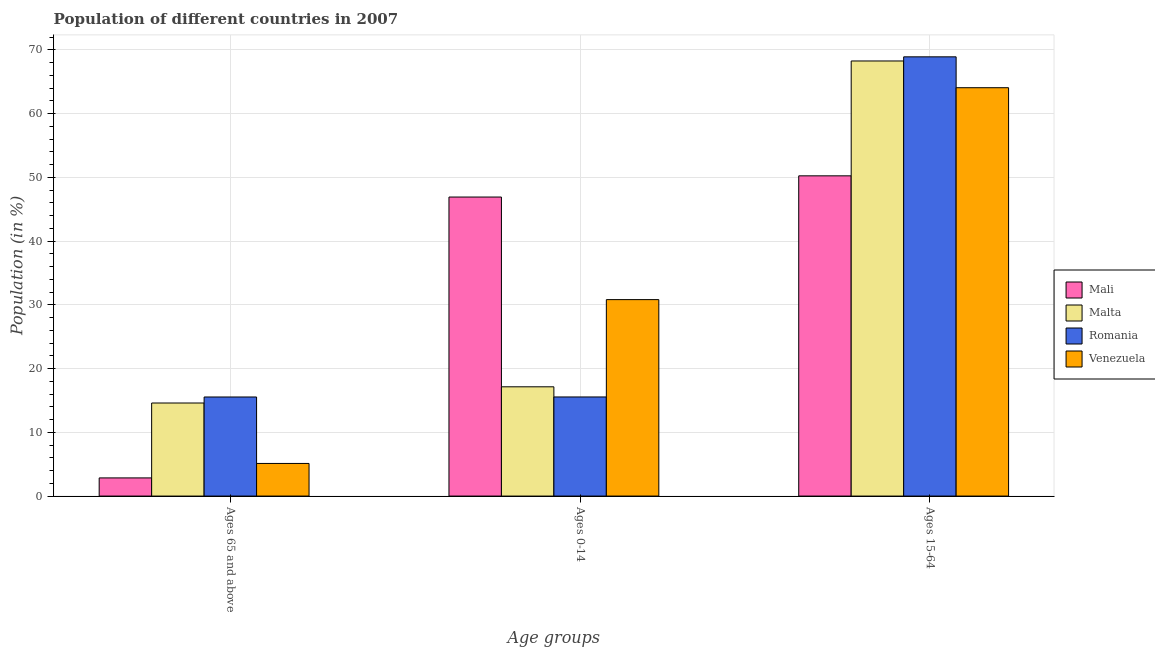How many different coloured bars are there?
Make the answer very short. 4. How many groups of bars are there?
Offer a very short reply. 3. How many bars are there on the 1st tick from the left?
Give a very brief answer. 4. What is the label of the 3rd group of bars from the left?
Make the answer very short. Ages 15-64. What is the percentage of population within the age-group of 65 and above in Romania?
Offer a terse response. 15.54. Across all countries, what is the maximum percentage of population within the age-group of 65 and above?
Provide a short and direct response. 15.54. Across all countries, what is the minimum percentage of population within the age-group 0-14?
Make the answer very short. 15.55. In which country was the percentage of population within the age-group 0-14 maximum?
Ensure brevity in your answer.  Mali. In which country was the percentage of population within the age-group 15-64 minimum?
Provide a short and direct response. Mali. What is the total percentage of population within the age-group of 65 and above in the graph?
Offer a very short reply. 38.11. What is the difference between the percentage of population within the age-group 0-14 in Mali and that in Romania?
Keep it short and to the point. 31.36. What is the difference between the percentage of population within the age-group 15-64 in Romania and the percentage of population within the age-group of 65 and above in Venezuela?
Ensure brevity in your answer.  63.79. What is the average percentage of population within the age-group 15-64 per country?
Offer a very short reply. 62.87. What is the difference between the percentage of population within the age-group 0-14 and percentage of population within the age-group of 65 and above in Romania?
Offer a terse response. 0. What is the ratio of the percentage of population within the age-group 0-14 in Venezuela to that in Mali?
Ensure brevity in your answer.  0.66. What is the difference between the highest and the second highest percentage of population within the age-group of 65 and above?
Offer a very short reply. 0.94. What is the difference between the highest and the lowest percentage of population within the age-group of 65 and above?
Your answer should be very brief. 12.7. In how many countries, is the percentage of population within the age-group 0-14 greater than the average percentage of population within the age-group 0-14 taken over all countries?
Provide a short and direct response. 2. What does the 4th bar from the left in Ages 65 and above represents?
Your answer should be very brief. Venezuela. What does the 2nd bar from the right in Ages 65 and above represents?
Give a very brief answer. Romania. Is it the case that in every country, the sum of the percentage of population within the age-group of 65 and above and percentage of population within the age-group 0-14 is greater than the percentage of population within the age-group 15-64?
Provide a succinct answer. No. How many bars are there?
Offer a terse response. 12. How many countries are there in the graph?
Provide a short and direct response. 4. Are the values on the major ticks of Y-axis written in scientific E-notation?
Your answer should be compact. No. Does the graph contain any zero values?
Provide a succinct answer. No. What is the title of the graph?
Offer a terse response. Population of different countries in 2007. Does "Tuvalu" appear as one of the legend labels in the graph?
Your answer should be compact. No. What is the label or title of the X-axis?
Your response must be concise. Age groups. What is the Population (in %) of Mali in Ages 65 and above?
Your answer should be very brief. 2.85. What is the Population (in %) in Malta in Ages 65 and above?
Your response must be concise. 14.6. What is the Population (in %) of Romania in Ages 65 and above?
Offer a terse response. 15.54. What is the Population (in %) of Venezuela in Ages 65 and above?
Offer a terse response. 5.12. What is the Population (in %) of Mali in Ages 0-14?
Offer a very short reply. 46.91. What is the Population (in %) in Malta in Ages 0-14?
Provide a succinct answer. 17.14. What is the Population (in %) of Romania in Ages 0-14?
Your response must be concise. 15.55. What is the Population (in %) in Venezuela in Ages 0-14?
Make the answer very short. 30.82. What is the Population (in %) of Mali in Ages 15-64?
Your answer should be compact. 50.24. What is the Population (in %) in Malta in Ages 15-64?
Offer a very short reply. 68.26. What is the Population (in %) in Romania in Ages 15-64?
Your response must be concise. 68.91. What is the Population (in %) of Venezuela in Ages 15-64?
Your answer should be very brief. 64.06. Across all Age groups, what is the maximum Population (in %) in Mali?
Keep it short and to the point. 50.24. Across all Age groups, what is the maximum Population (in %) of Malta?
Provide a succinct answer. 68.26. Across all Age groups, what is the maximum Population (in %) of Romania?
Provide a succinct answer. 68.91. Across all Age groups, what is the maximum Population (in %) in Venezuela?
Offer a very short reply. 64.06. Across all Age groups, what is the minimum Population (in %) in Mali?
Provide a short and direct response. 2.85. Across all Age groups, what is the minimum Population (in %) in Malta?
Make the answer very short. 14.6. Across all Age groups, what is the minimum Population (in %) of Romania?
Give a very brief answer. 15.54. Across all Age groups, what is the minimum Population (in %) in Venezuela?
Your response must be concise. 5.12. What is the total Population (in %) in Romania in the graph?
Your answer should be very brief. 100. What is the difference between the Population (in %) in Mali in Ages 65 and above and that in Ages 0-14?
Offer a terse response. -44.06. What is the difference between the Population (in %) of Malta in Ages 65 and above and that in Ages 0-14?
Offer a terse response. -2.54. What is the difference between the Population (in %) in Romania in Ages 65 and above and that in Ages 0-14?
Offer a terse response. -0. What is the difference between the Population (in %) in Venezuela in Ages 65 and above and that in Ages 0-14?
Offer a terse response. -25.7. What is the difference between the Population (in %) in Mali in Ages 65 and above and that in Ages 15-64?
Provide a short and direct response. -47.39. What is the difference between the Population (in %) in Malta in Ages 65 and above and that in Ages 15-64?
Make the answer very short. -53.66. What is the difference between the Population (in %) of Romania in Ages 65 and above and that in Ages 15-64?
Give a very brief answer. -53.36. What is the difference between the Population (in %) of Venezuela in Ages 65 and above and that in Ages 15-64?
Your answer should be compact. -58.95. What is the difference between the Population (in %) in Mali in Ages 0-14 and that in Ages 15-64?
Your answer should be compact. -3.33. What is the difference between the Population (in %) of Malta in Ages 0-14 and that in Ages 15-64?
Your answer should be very brief. -51.12. What is the difference between the Population (in %) of Romania in Ages 0-14 and that in Ages 15-64?
Keep it short and to the point. -53.36. What is the difference between the Population (in %) in Venezuela in Ages 0-14 and that in Ages 15-64?
Ensure brevity in your answer.  -33.24. What is the difference between the Population (in %) of Mali in Ages 65 and above and the Population (in %) of Malta in Ages 0-14?
Offer a very short reply. -14.29. What is the difference between the Population (in %) in Mali in Ages 65 and above and the Population (in %) in Romania in Ages 0-14?
Make the answer very short. -12.7. What is the difference between the Population (in %) in Mali in Ages 65 and above and the Population (in %) in Venezuela in Ages 0-14?
Provide a short and direct response. -27.97. What is the difference between the Population (in %) in Malta in Ages 65 and above and the Population (in %) in Romania in Ages 0-14?
Your response must be concise. -0.95. What is the difference between the Population (in %) of Malta in Ages 65 and above and the Population (in %) of Venezuela in Ages 0-14?
Make the answer very short. -16.22. What is the difference between the Population (in %) in Romania in Ages 65 and above and the Population (in %) in Venezuela in Ages 0-14?
Offer a terse response. -15.28. What is the difference between the Population (in %) of Mali in Ages 65 and above and the Population (in %) of Malta in Ages 15-64?
Give a very brief answer. -65.41. What is the difference between the Population (in %) in Mali in Ages 65 and above and the Population (in %) in Romania in Ages 15-64?
Provide a short and direct response. -66.06. What is the difference between the Population (in %) in Mali in Ages 65 and above and the Population (in %) in Venezuela in Ages 15-64?
Make the answer very short. -61.22. What is the difference between the Population (in %) in Malta in Ages 65 and above and the Population (in %) in Romania in Ages 15-64?
Keep it short and to the point. -54.31. What is the difference between the Population (in %) of Malta in Ages 65 and above and the Population (in %) of Venezuela in Ages 15-64?
Provide a succinct answer. -49.46. What is the difference between the Population (in %) in Romania in Ages 65 and above and the Population (in %) in Venezuela in Ages 15-64?
Provide a succinct answer. -48.52. What is the difference between the Population (in %) in Mali in Ages 0-14 and the Population (in %) in Malta in Ages 15-64?
Make the answer very short. -21.34. What is the difference between the Population (in %) in Mali in Ages 0-14 and the Population (in %) in Romania in Ages 15-64?
Make the answer very short. -21.99. What is the difference between the Population (in %) in Mali in Ages 0-14 and the Population (in %) in Venezuela in Ages 15-64?
Keep it short and to the point. -17.15. What is the difference between the Population (in %) of Malta in Ages 0-14 and the Population (in %) of Romania in Ages 15-64?
Offer a very short reply. -51.77. What is the difference between the Population (in %) in Malta in Ages 0-14 and the Population (in %) in Venezuela in Ages 15-64?
Give a very brief answer. -46.92. What is the difference between the Population (in %) in Romania in Ages 0-14 and the Population (in %) in Venezuela in Ages 15-64?
Offer a terse response. -48.52. What is the average Population (in %) in Mali per Age groups?
Provide a succinct answer. 33.33. What is the average Population (in %) of Malta per Age groups?
Offer a terse response. 33.33. What is the average Population (in %) in Romania per Age groups?
Ensure brevity in your answer.  33.33. What is the average Population (in %) in Venezuela per Age groups?
Provide a short and direct response. 33.33. What is the difference between the Population (in %) of Mali and Population (in %) of Malta in Ages 65 and above?
Your answer should be very brief. -11.75. What is the difference between the Population (in %) in Mali and Population (in %) in Romania in Ages 65 and above?
Provide a succinct answer. -12.7. What is the difference between the Population (in %) of Mali and Population (in %) of Venezuela in Ages 65 and above?
Offer a terse response. -2.27. What is the difference between the Population (in %) in Malta and Population (in %) in Romania in Ages 65 and above?
Provide a succinct answer. -0.94. What is the difference between the Population (in %) of Malta and Population (in %) of Venezuela in Ages 65 and above?
Provide a succinct answer. 9.48. What is the difference between the Population (in %) in Romania and Population (in %) in Venezuela in Ages 65 and above?
Offer a very short reply. 10.43. What is the difference between the Population (in %) of Mali and Population (in %) of Malta in Ages 0-14?
Your answer should be very brief. 29.77. What is the difference between the Population (in %) of Mali and Population (in %) of Romania in Ages 0-14?
Make the answer very short. 31.36. What is the difference between the Population (in %) of Mali and Population (in %) of Venezuela in Ages 0-14?
Your answer should be very brief. 16.09. What is the difference between the Population (in %) in Malta and Population (in %) in Romania in Ages 0-14?
Offer a terse response. 1.59. What is the difference between the Population (in %) in Malta and Population (in %) in Venezuela in Ages 0-14?
Offer a terse response. -13.68. What is the difference between the Population (in %) in Romania and Population (in %) in Venezuela in Ages 0-14?
Your answer should be compact. -15.27. What is the difference between the Population (in %) of Mali and Population (in %) of Malta in Ages 15-64?
Your answer should be compact. -18.02. What is the difference between the Population (in %) in Mali and Population (in %) in Romania in Ages 15-64?
Give a very brief answer. -18.67. What is the difference between the Population (in %) in Mali and Population (in %) in Venezuela in Ages 15-64?
Ensure brevity in your answer.  -13.82. What is the difference between the Population (in %) of Malta and Population (in %) of Romania in Ages 15-64?
Make the answer very short. -0.65. What is the difference between the Population (in %) in Malta and Population (in %) in Venezuela in Ages 15-64?
Offer a terse response. 4.19. What is the difference between the Population (in %) of Romania and Population (in %) of Venezuela in Ages 15-64?
Your answer should be very brief. 4.84. What is the ratio of the Population (in %) of Mali in Ages 65 and above to that in Ages 0-14?
Keep it short and to the point. 0.06. What is the ratio of the Population (in %) in Malta in Ages 65 and above to that in Ages 0-14?
Make the answer very short. 0.85. What is the ratio of the Population (in %) in Romania in Ages 65 and above to that in Ages 0-14?
Ensure brevity in your answer.  1. What is the ratio of the Population (in %) of Venezuela in Ages 65 and above to that in Ages 0-14?
Keep it short and to the point. 0.17. What is the ratio of the Population (in %) of Mali in Ages 65 and above to that in Ages 15-64?
Give a very brief answer. 0.06. What is the ratio of the Population (in %) in Malta in Ages 65 and above to that in Ages 15-64?
Keep it short and to the point. 0.21. What is the ratio of the Population (in %) in Romania in Ages 65 and above to that in Ages 15-64?
Give a very brief answer. 0.23. What is the ratio of the Population (in %) of Venezuela in Ages 65 and above to that in Ages 15-64?
Offer a terse response. 0.08. What is the ratio of the Population (in %) of Mali in Ages 0-14 to that in Ages 15-64?
Make the answer very short. 0.93. What is the ratio of the Population (in %) in Malta in Ages 0-14 to that in Ages 15-64?
Keep it short and to the point. 0.25. What is the ratio of the Population (in %) in Romania in Ages 0-14 to that in Ages 15-64?
Provide a short and direct response. 0.23. What is the ratio of the Population (in %) of Venezuela in Ages 0-14 to that in Ages 15-64?
Offer a terse response. 0.48. What is the difference between the highest and the second highest Population (in %) of Mali?
Give a very brief answer. 3.33. What is the difference between the highest and the second highest Population (in %) in Malta?
Make the answer very short. 51.12. What is the difference between the highest and the second highest Population (in %) of Romania?
Your response must be concise. 53.36. What is the difference between the highest and the second highest Population (in %) in Venezuela?
Offer a terse response. 33.24. What is the difference between the highest and the lowest Population (in %) of Mali?
Your response must be concise. 47.39. What is the difference between the highest and the lowest Population (in %) of Malta?
Keep it short and to the point. 53.66. What is the difference between the highest and the lowest Population (in %) of Romania?
Offer a very short reply. 53.36. What is the difference between the highest and the lowest Population (in %) of Venezuela?
Ensure brevity in your answer.  58.95. 